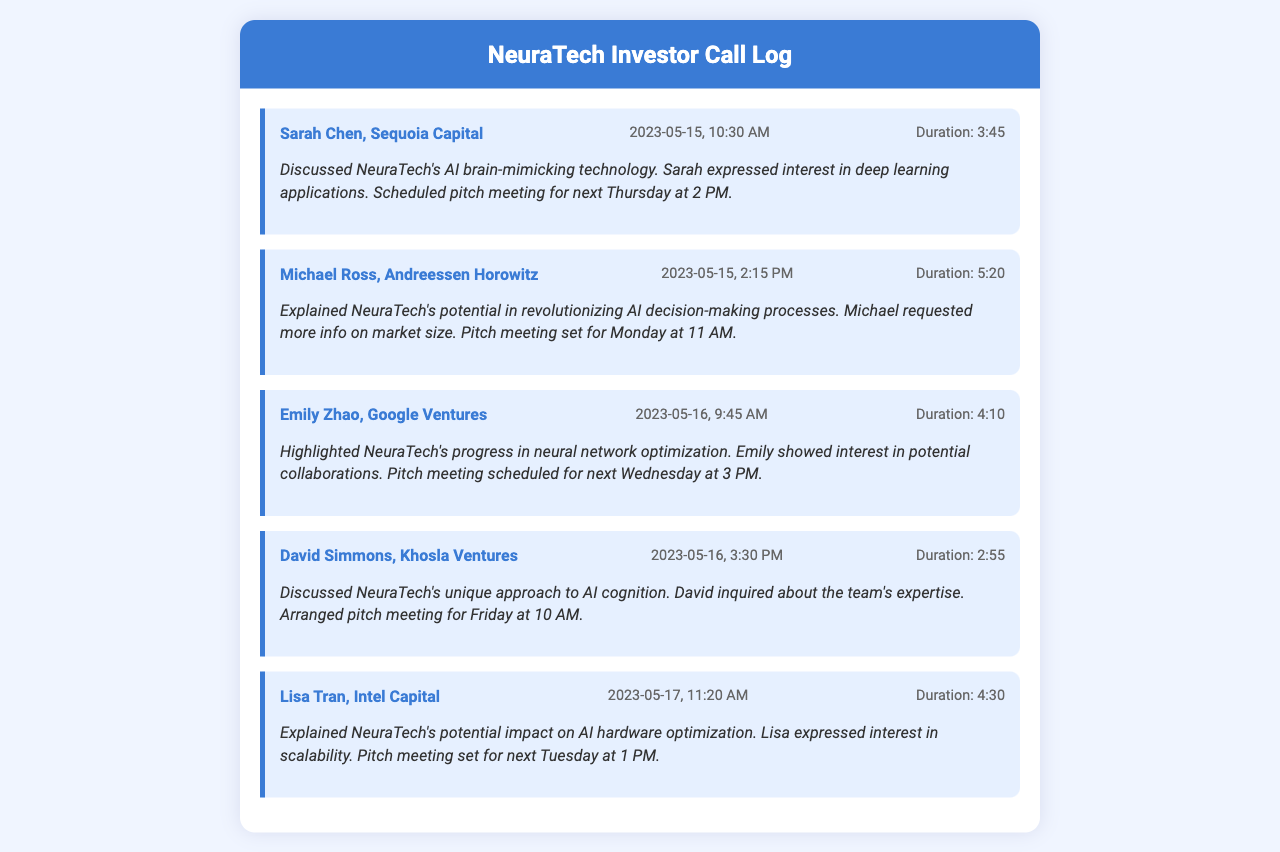What is the name of the first investor? The first investor listed in the document is Sarah Chen from Sequoia Capital.
Answer: Sarah Chen, Sequoia Capital When was the call with Michael Ross made? The call with Michael Ross was made on May 15, 2023, at 2:15 PM.
Answer: 2023-05-15, 2:15 PM What was the duration of the call with David Simmons? The duration of the call with David Simmons was 2 minutes and 55 seconds.
Answer: 2:55 On which date is the pitch meeting with Emily Zhao scheduled? The pitch meeting with Emily Zhao is scheduled for next Wednesday, which is May 24, 2023.
Answer: May 24, 2023 What interested Lisa Tran during her call? Lisa Tran expressed interest in scalability related to NeuraTech's technology.
Answer: Scalability How many investors were contacted on May 16, 2023? Two investors were contacted on May 16, 2023: Emily Zhao and David Simmons.
Answer: Two What topic was discussed with Michael Ross? The topic discussed with Michael Ross was NeuraTech's potential in revolutionizing AI decision-making processes.
Answer: AI decision-making processes Which company is David Simmons associated with? David Simmons is associated with Khosla Ventures.
Answer: Khosla Ventures What was the outcome of the conversation with Sarah Chen? The outcome was scheduling a pitch meeting for the following Thursday at 2 PM.
Answer: Pitch meeting set for Thursday at 2 PM 